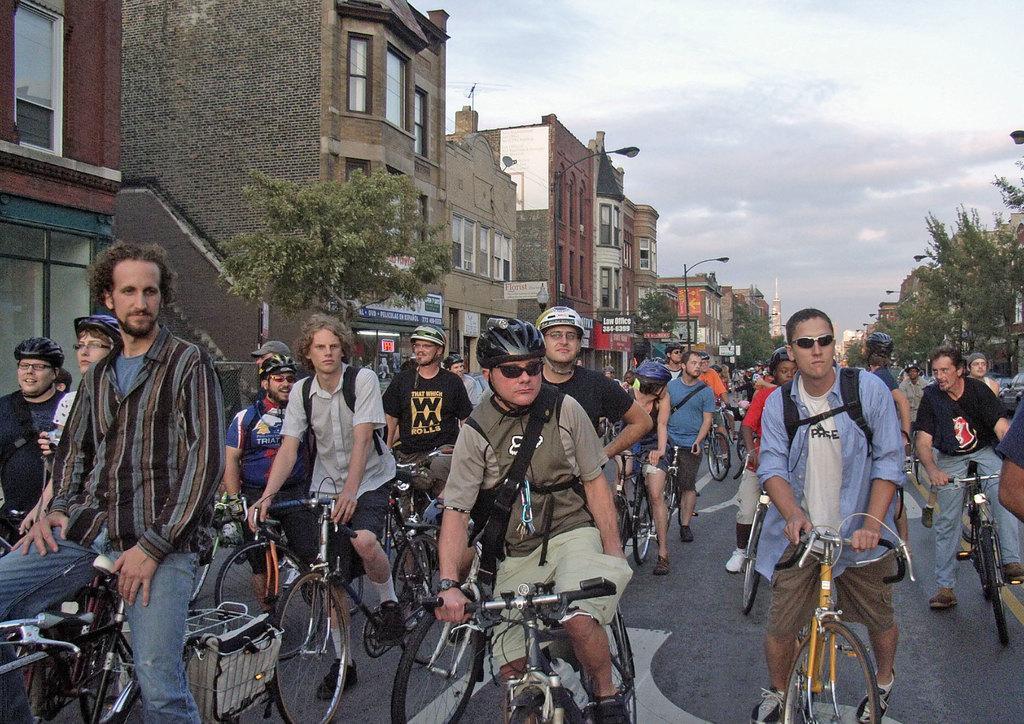How would you summarize this image in a sentence or two? In this picture we can see the people on their bicycle on the road,here we can see the trees with the clear sky,here we can see the street lights,here we can also see the buildings near to the road. 